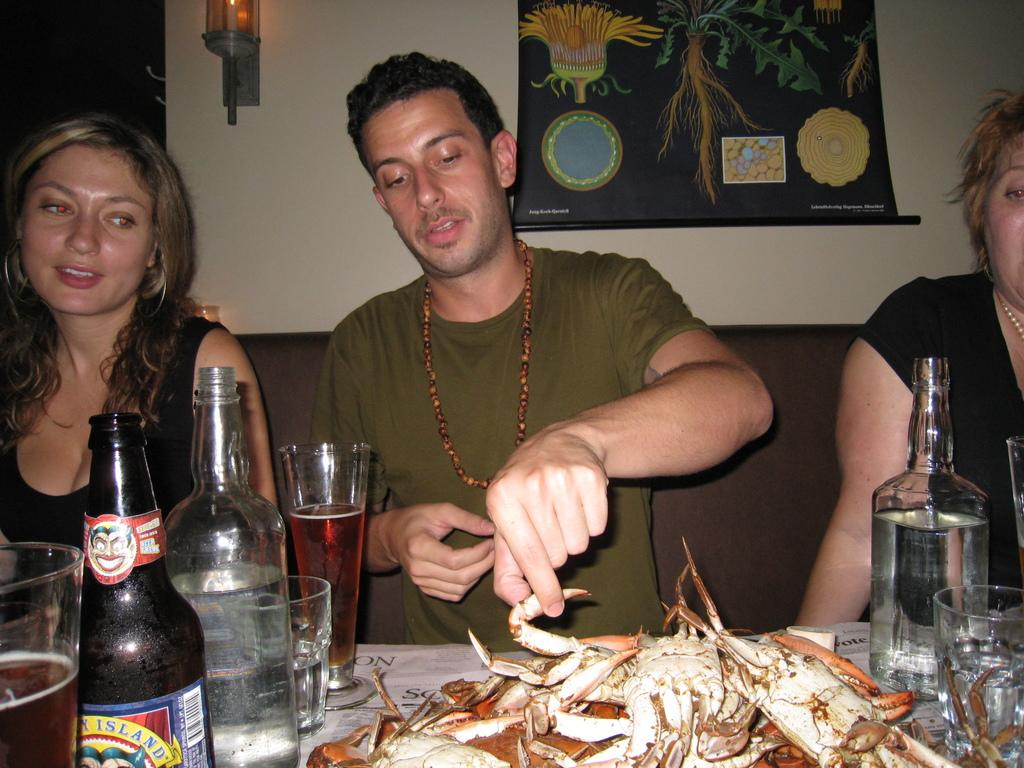How many people are in the image? There are three persons in the image. What are the persons doing in the image? The persons are sitting on a sofa. What is in front of the sofa? There is a table in front of the sofa. What can be found on the table? There are eatables and drinks on the table. What type of beam is supporting the ceiling in the image? There is no beam visible in the image, as it focuses on the persons sitting on the sofa and the table in front of them. 